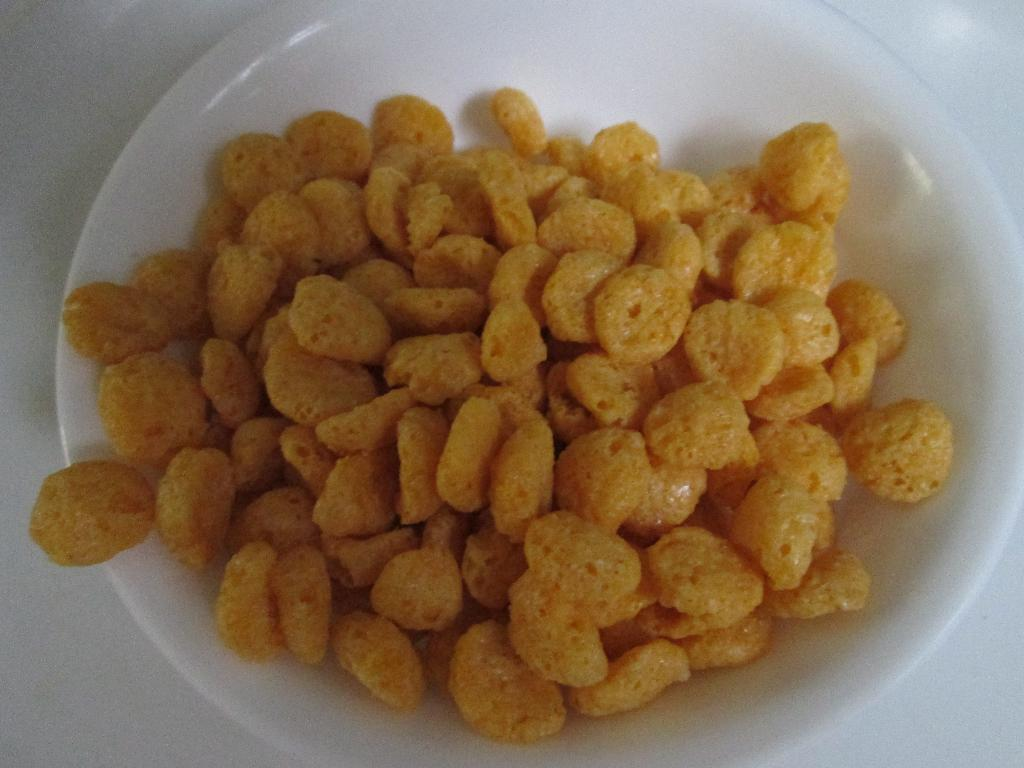What type of food is on the plate in the image? There are chips on a plate in the image. Where is the plate located? The plate is placed on a table. What type of skirt is visible in the image? There is no skirt present in the image; it only features a plate of chips on a table. 